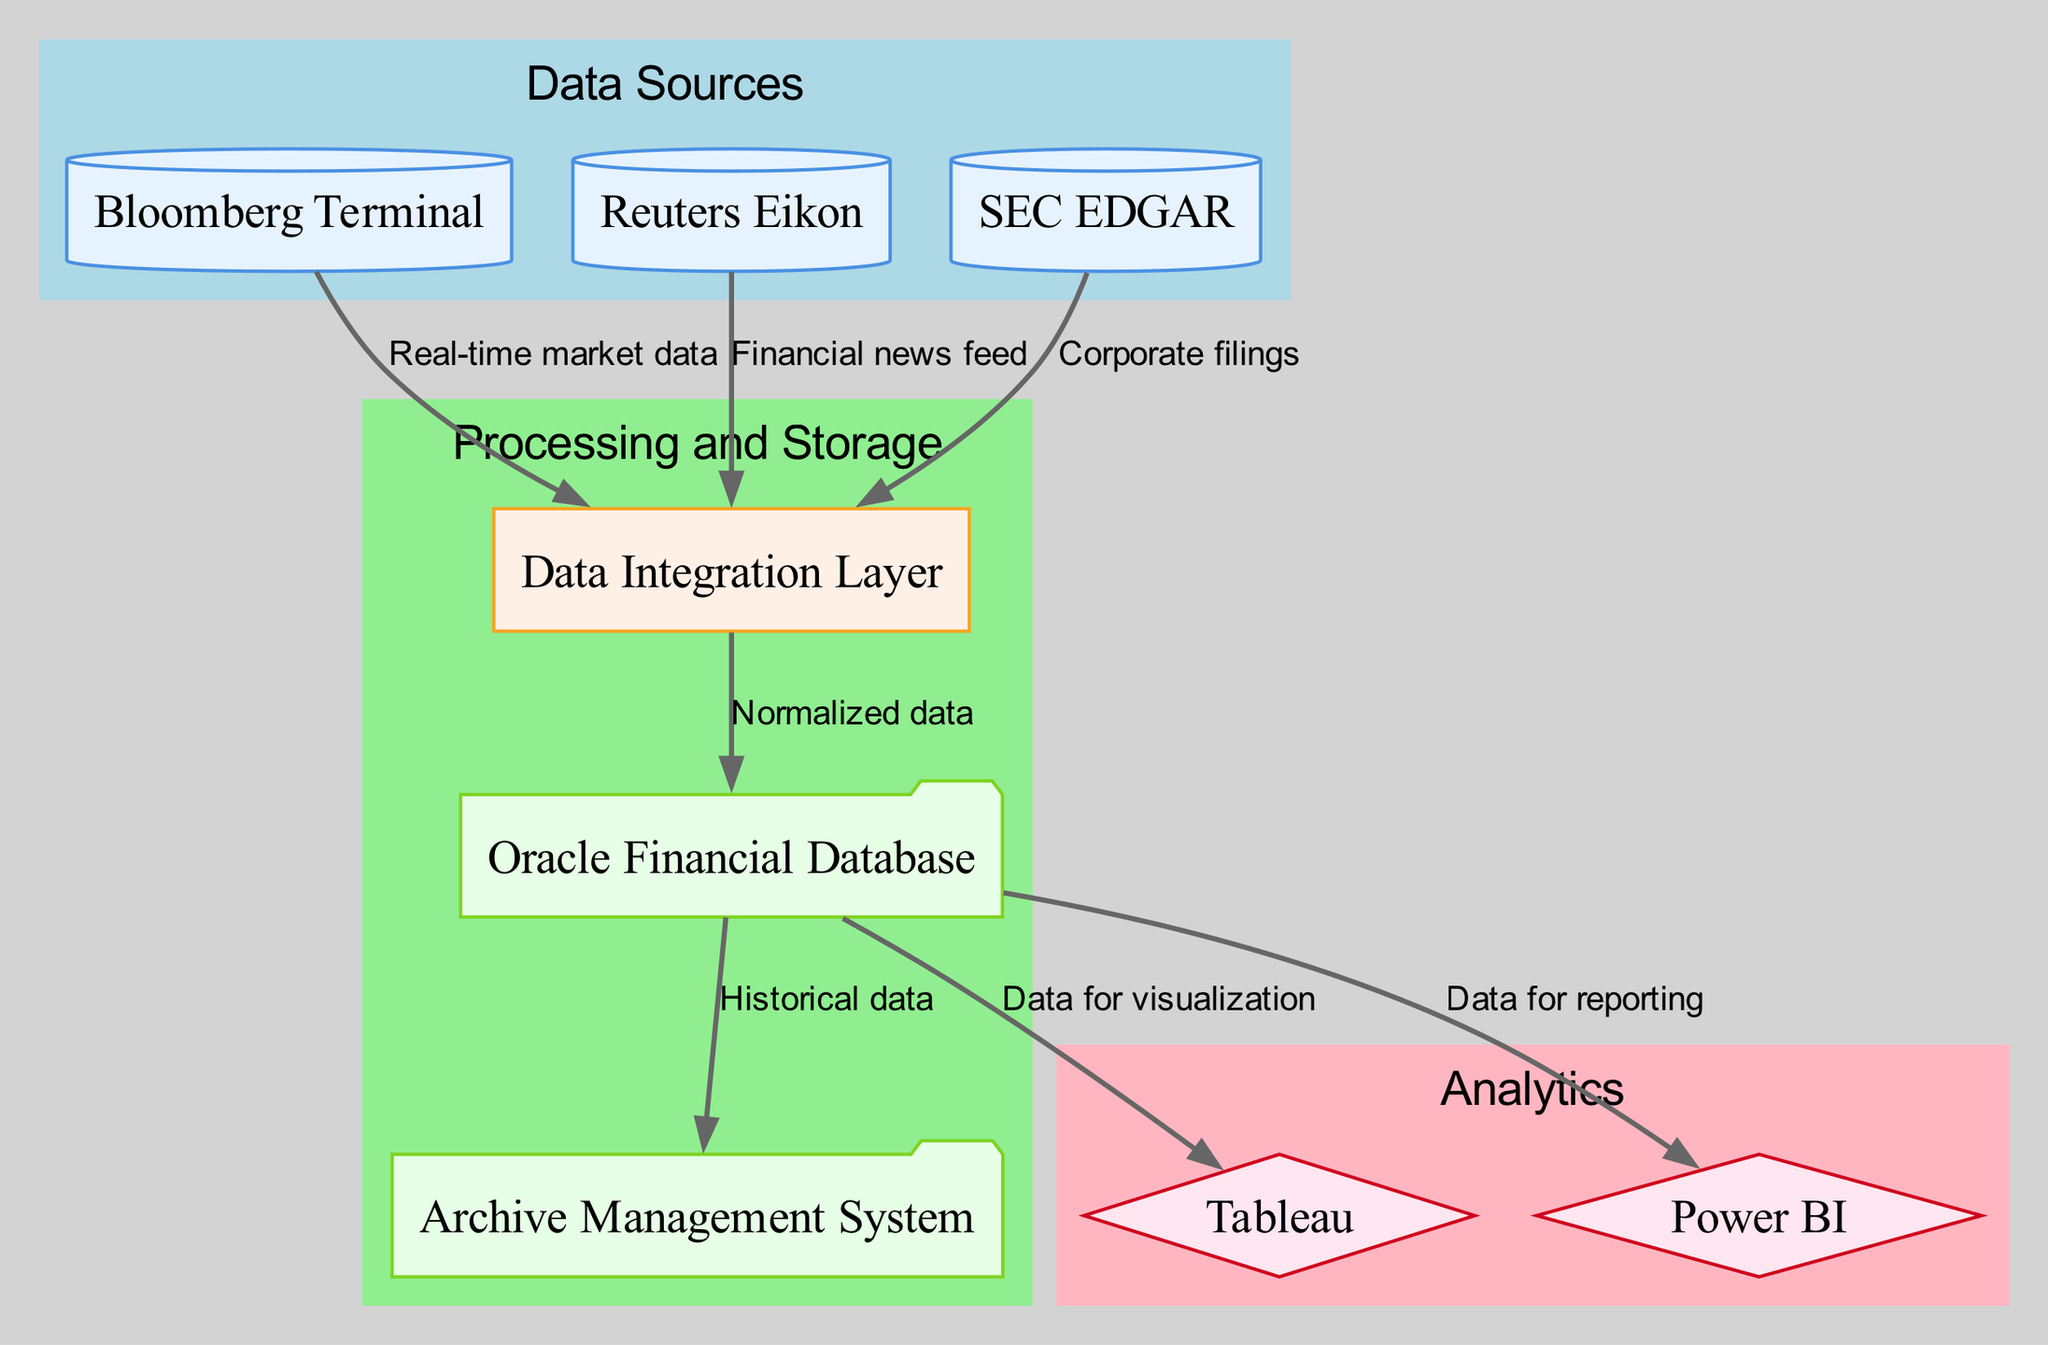What are the data sources shown in the diagram? The nodes labeled as "Bloomberg Terminal," "Reuters Eikon," and "SEC EDGAR" are identified as data sources. These can be seen at the top of the diagram, categorized under the "Data Sources" subgraph.
Answer: Bloomberg Terminal, Reuters Eikon, SEC EDGAR How many analytics tools are displayed? The diagram has two nodes labeled as analytics tools: "Tableau" and "Power BI." Counting these tools in the "Analytics" subgraph shows that there are two of them.
Answer: 2 Which data source provides corporate filings? By looking at the edges leading into the "Data Integration Layer," it is evident that "SEC EDGAR" is the source providing corporate filings, as indicated by the label on the edge connecting these two nodes.
Answer: SEC EDGAR What type of processing is indicated in the diagram? The node labeled "Data Integration Layer" indicates processing, as it is categorized under the "Processing" type in the diagram's taxonomy. It acts as a bridge between the data sources and the storage and analytics tools.
Answer: Processing What does the "Oracle Financial Database" store? The "Oracle Financial Database" node is connected to multiple edges, and it is designated for storing "Normalized data" before it is used for visualization or reporting. This means the database primarily holds refined and structured financial data derived from the data integration process.
Answer: Normalized data Which analytics tool is used for reporting? The edge connecting "Oracle Financial Database" to "Power BI" is labeled "Data for reporting," indicating that this tool is specifically intended for generating reports based on the financial data stored in the database.
Answer: Power BI How many edges connect data sources to the processing layer? Each data source connects to the processing layer via a directed edge. There are three edges from "Bloomberg Terminal," "Reuters Eikon," and "SEC EDGAR" to the "Data Integration Layer." This totals to three connections in the diagram.
Answer: 3 What is stored as historical data according to the diagram? The node labeled "Archive Management System" is designated for storing historical data according to the edges leading out from the "Oracle Financial Database." This indicates that the historical dimensions of financial data are managed here.
Answer: Historical data Describe the flow from data sources to analytics tools in the diagram. The diagram illustrates a flow from three data sources into the "Data Integration Layer," where the data is processed into a normalized format, stored in the "Oracle Financial Database," and subsequently channeled to the analytics tools "Tableau" and "Power BI" for visualization and reporting purposes. This sequential flow indicates the data lifecycle in the architecture captured in the diagram.
Answer: Data flow from sources to analytics tools 